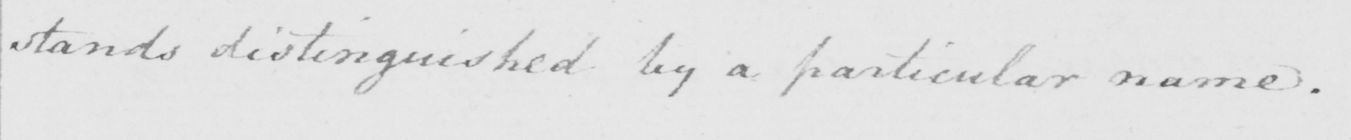Can you read and transcribe this handwriting? stands distinguished by a particular name . 